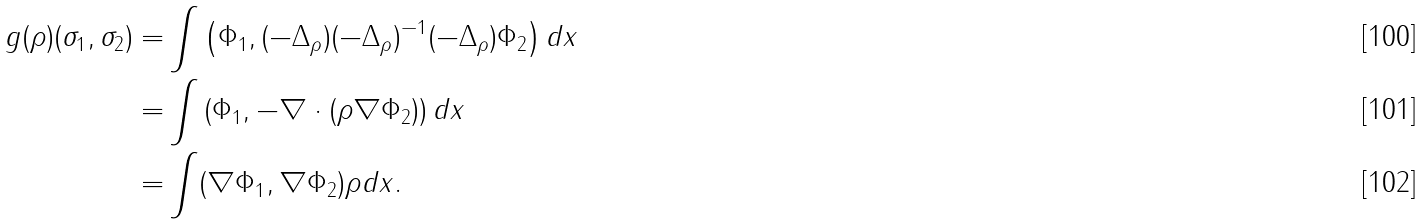Convert formula to latex. <formula><loc_0><loc_0><loc_500><loc_500>\ g ( \rho ) ( \sigma _ { 1 } , \sigma _ { 2 } ) = & \int \left ( \Phi _ { 1 } , ( - \Delta _ { \rho } ) ( - \Delta _ { \rho } ) ^ { - 1 } ( - \Delta _ { \rho } ) \Phi _ { 2 } \right ) d x \\ = & \int \left ( \Phi _ { 1 } , - \nabla \cdot ( \rho \nabla \Phi _ { 2 } ) \right ) d x \\ = & \int ( \nabla \Phi _ { 1 } , \nabla \Phi _ { 2 } ) \rho d x .</formula> 